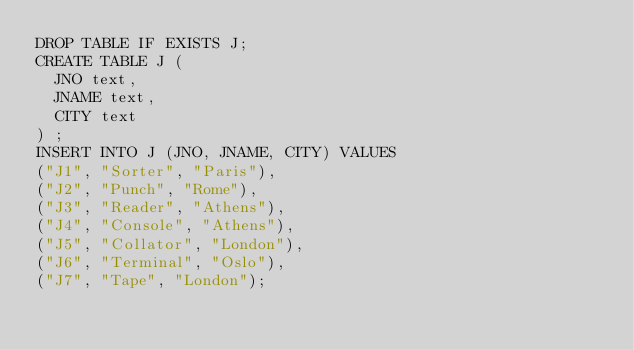Convert code to text. <code><loc_0><loc_0><loc_500><loc_500><_SQL_>DROP TABLE IF EXISTS J;
CREATE TABLE J (
  JNO text,
  JNAME text,
  CITY text
) ;
INSERT INTO J (JNO, JNAME, CITY) VALUES
("J1", "Sorter", "Paris"),
("J2", "Punch", "Rome"),
("J3", "Reader", "Athens"),
("J4", "Console", "Athens"),
("J5", "Collator", "London"),
("J6", "Terminal", "Oslo"),
("J7", "Tape", "London");
</code> 